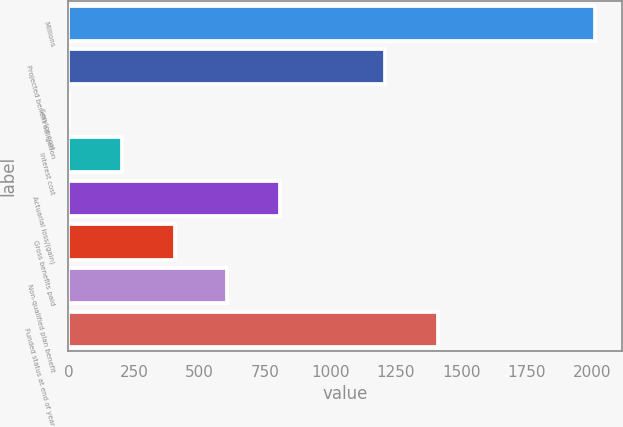Convert chart. <chart><loc_0><loc_0><loc_500><loc_500><bar_chart><fcel>Millions<fcel>Projected benefit obligation<fcel>Service cost<fcel>Interest cost<fcel>Actuarial loss/(gain)<fcel>Gross benefits paid<fcel>Non-qualified plan benefit<fcel>Funded status at end of year<nl><fcel>2012<fcel>1208.4<fcel>3<fcel>203.9<fcel>806.6<fcel>404.8<fcel>605.7<fcel>1409.3<nl></chart> 